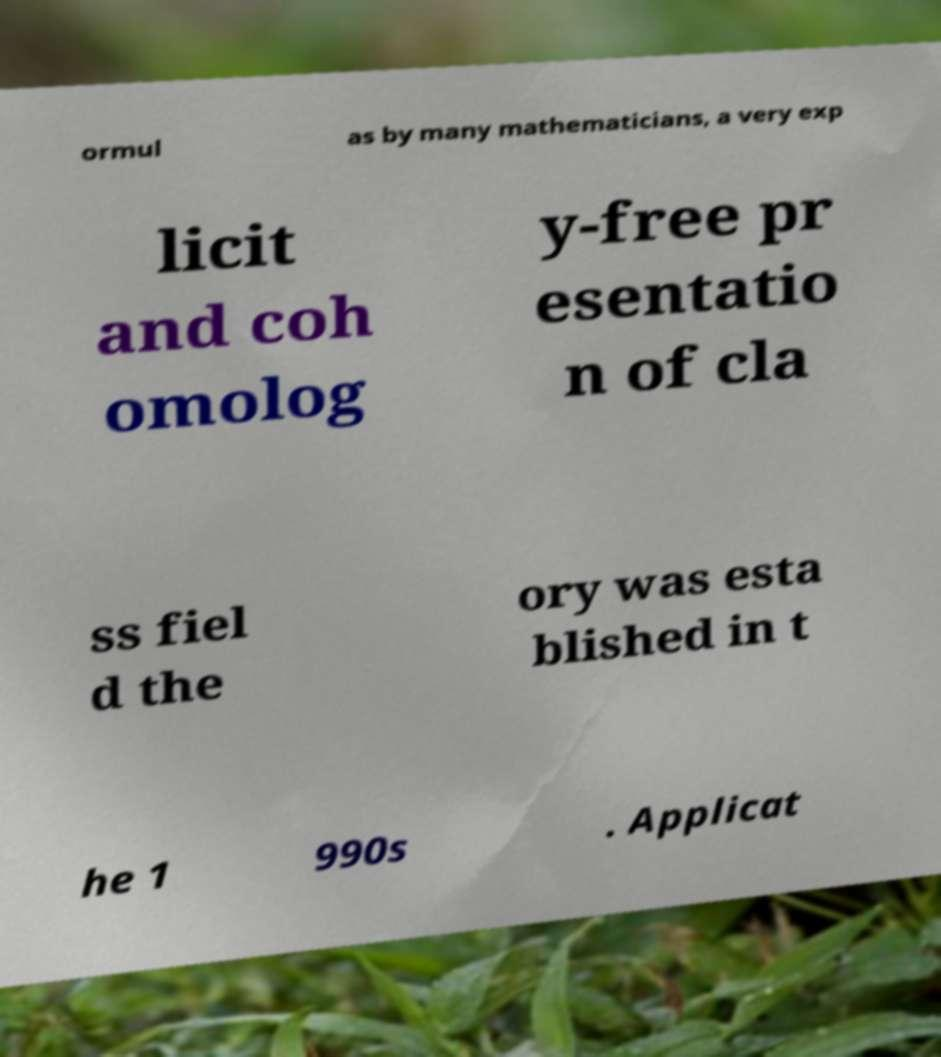I need the written content from this picture converted into text. Can you do that? ormul as by many mathematicians, a very exp licit and coh omolog y-free pr esentatio n of cla ss fiel d the ory was esta blished in t he 1 990s . Applicat 